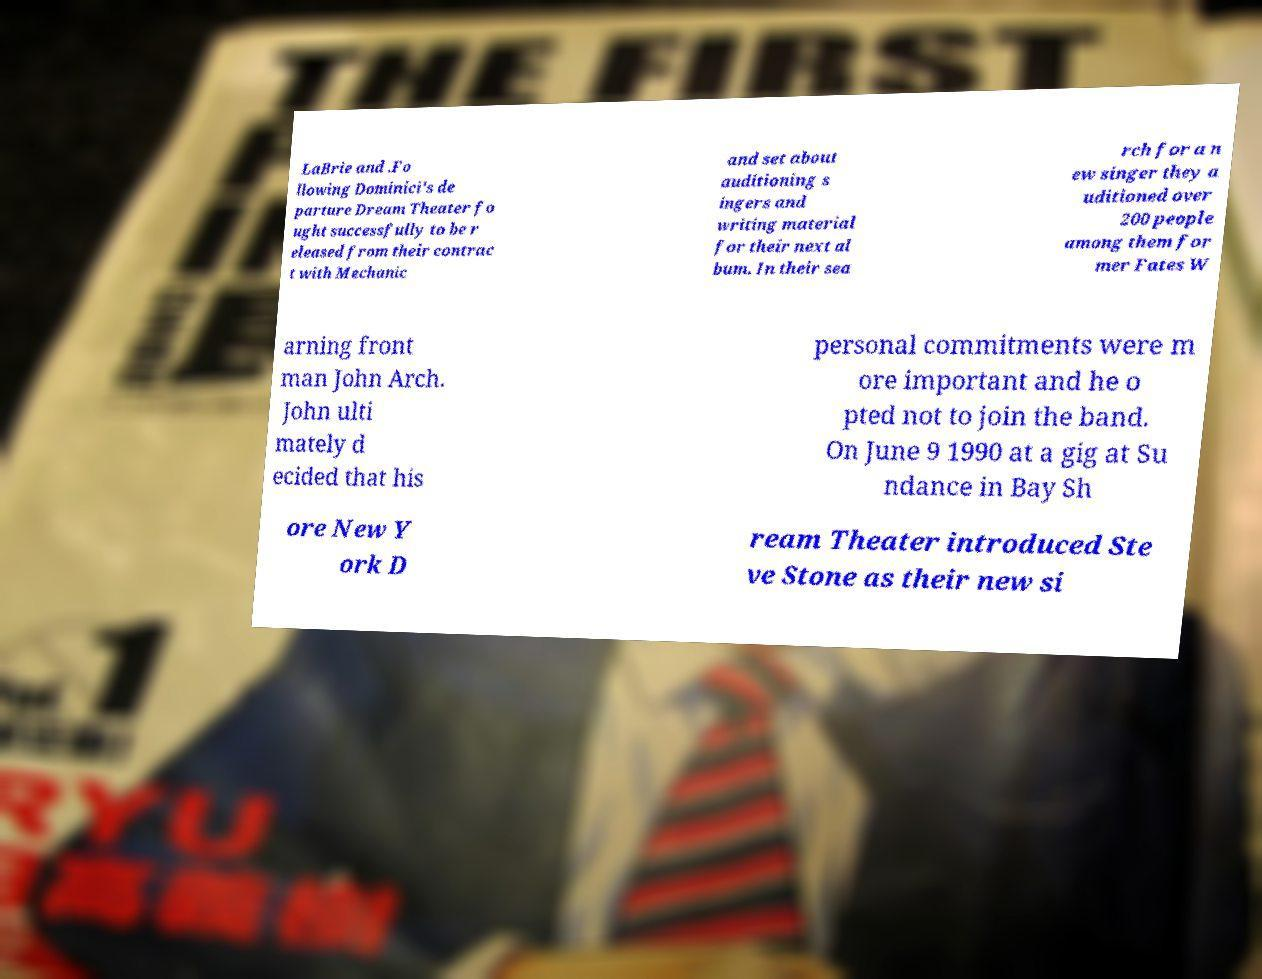Please identify and transcribe the text found in this image. LaBrie and .Fo llowing Dominici's de parture Dream Theater fo ught successfully to be r eleased from their contrac t with Mechanic and set about auditioning s ingers and writing material for their next al bum. In their sea rch for a n ew singer they a uditioned over 200 people among them for mer Fates W arning front man John Arch. John ulti mately d ecided that his personal commitments were m ore important and he o pted not to join the band. On June 9 1990 at a gig at Su ndance in Bay Sh ore New Y ork D ream Theater introduced Ste ve Stone as their new si 